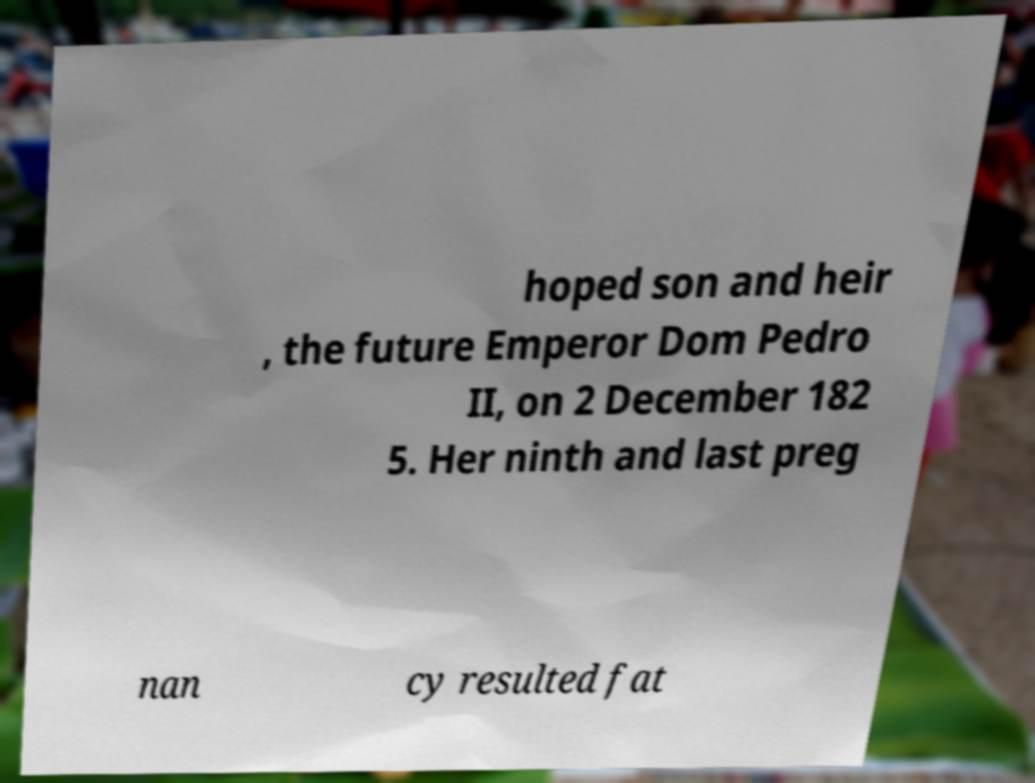Can you read and provide the text displayed in the image?This photo seems to have some interesting text. Can you extract and type it out for me? hoped son and heir , the future Emperor Dom Pedro II, on 2 December 182 5. Her ninth and last preg nan cy resulted fat 